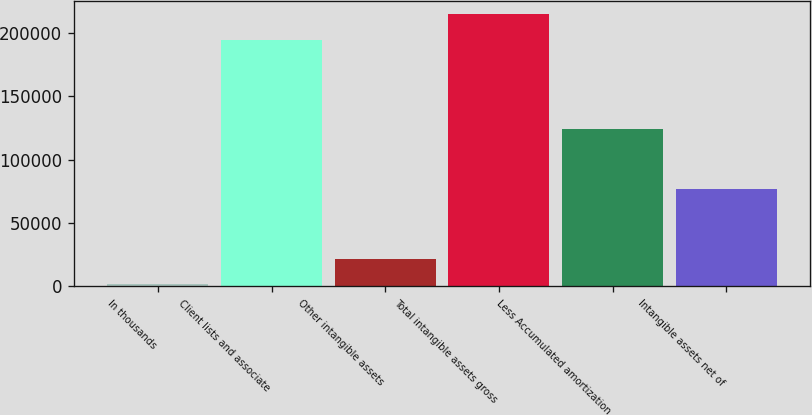Convert chart. <chart><loc_0><loc_0><loc_500><loc_500><bar_chart><fcel>In thousands<fcel>Client lists and associate<fcel>Other intangible assets<fcel>Total intangible assets gross<fcel>Less Accumulated amortization<fcel>Intangible assets net of<nl><fcel>2009<fcel>194887<fcel>21864.3<fcel>214742<fcel>123921<fcel>76641<nl></chart> 